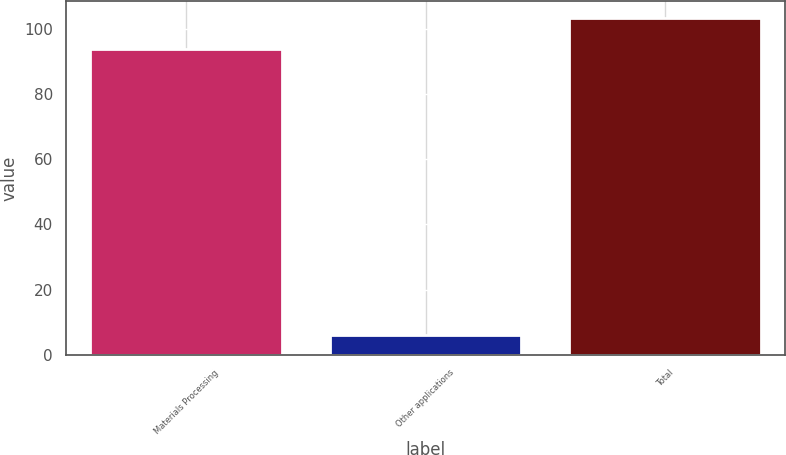<chart> <loc_0><loc_0><loc_500><loc_500><bar_chart><fcel>Materials Processing<fcel>Other applications<fcel>Total<nl><fcel>93.9<fcel>6.1<fcel>103.29<nl></chart> 